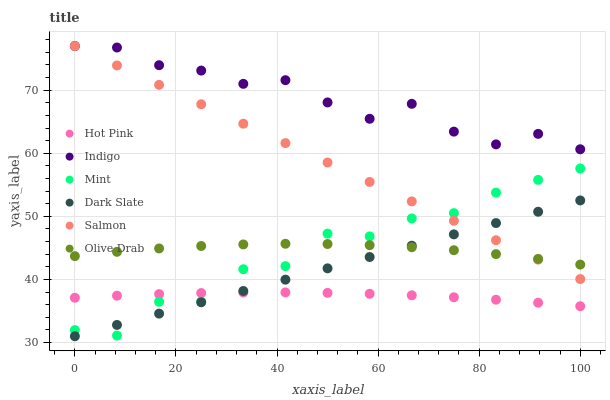Does Hot Pink have the minimum area under the curve?
Answer yes or no. Yes. Does Indigo have the maximum area under the curve?
Answer yes or no. Yes. Does Salmon have the minimum area under the curve?
Answer yes or no. No. Does Salmon have the maximum area under the curve?
Answer yes or no. No. Is Dark Slate the smoothest?
Answer yes or no. Yes. Is Mint the roughest?
Answer yes or no. Yes. Is Hot Pink the smoothest?
Answer yes or no. No. Is Hot Pink the roughest?
Answer yes or no. No. Does Dark Slate have the lowest value?
Answer yes or no. Yes. Does Hot Pink have the lowest value?
Answer yes or no. No. Does Salmon have the highest value?
Answer yes or no. Yes. Does Hot Pink have the highest value?
Answer yes or no. No. Is Hot Pink less than Salmon?
Answer yes or no. Yes. Is Indigo greater than Dark Slate?
Answer yes or no. Yes. Does Dark Slate intersect Hot Pink?
Answer yes or no. Yes. Is Dark Slate less than Hot Pink?
Answer yes or no. No. Is Dark Slate greater than Hot Pink?
Answer yes or no. No. Does Hot Pink intersect Salmon?
Answer yes or no. No. 